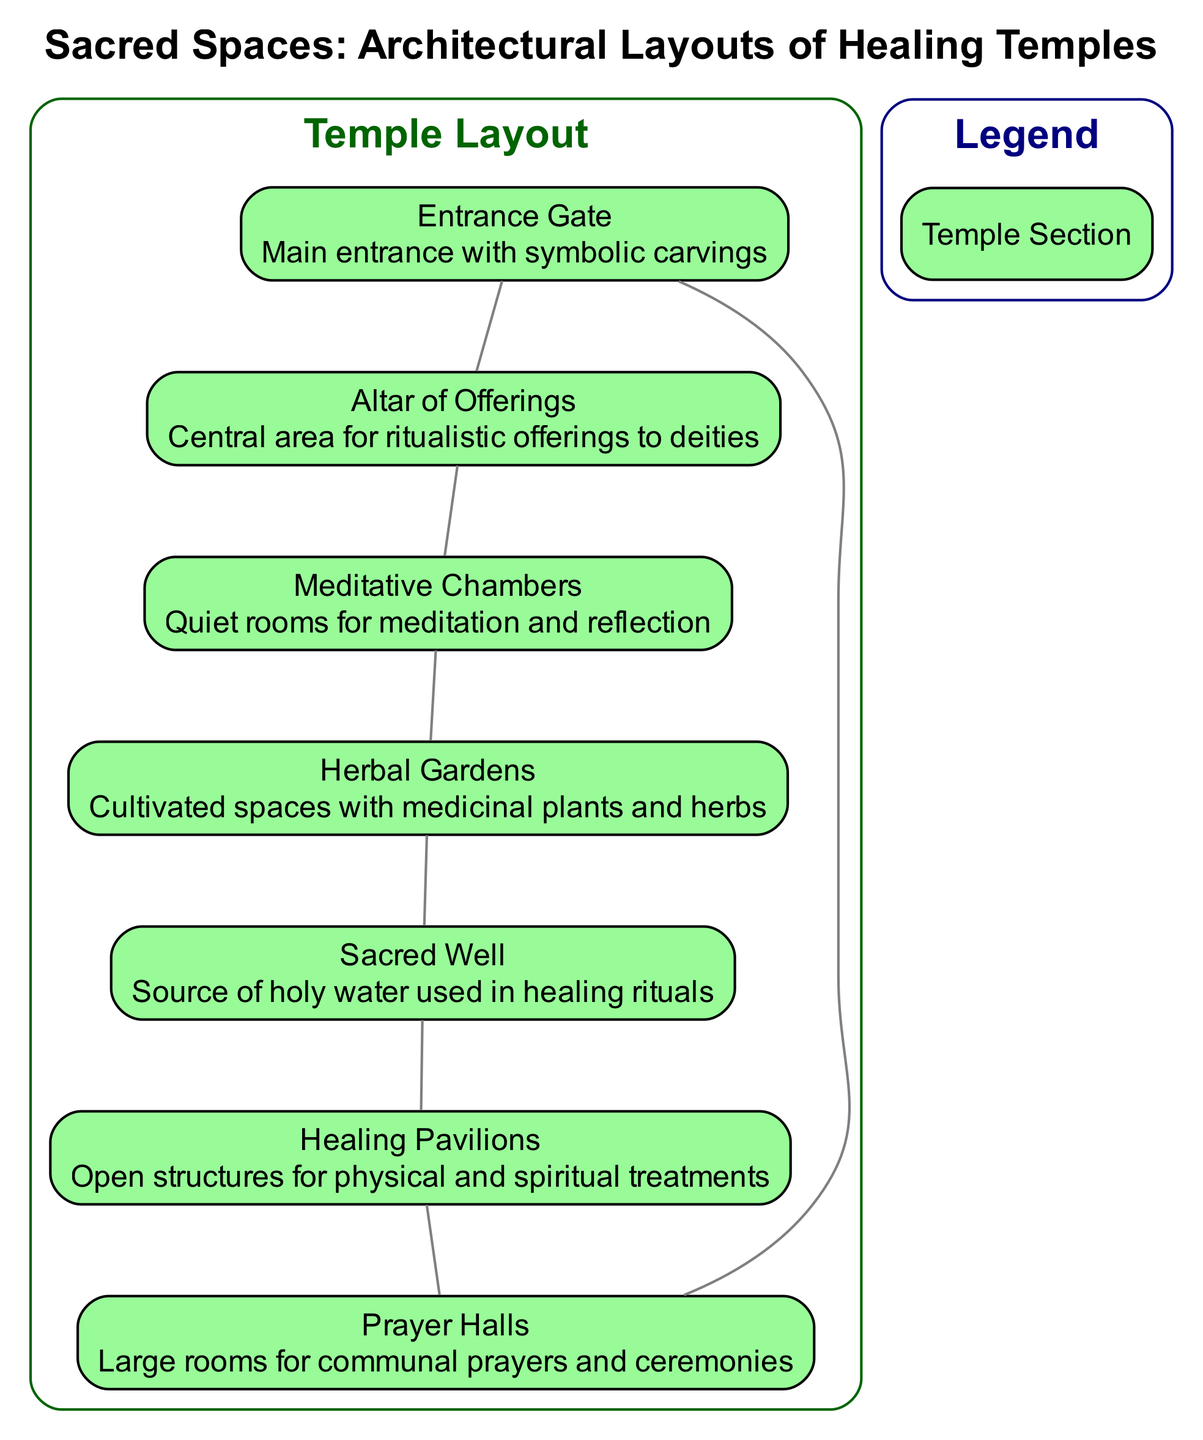What is the main feature found at the entrance of the healing temple? The diagram indicates that the main feature at the entrance is labeled "Entrance Gate" and is described as having symbolic carvings.
Answer: Entrance Gate How many sections are there in the healing temple layout? By counting the sections listed in the diagram, we see that there are a total of 7 sections identified.
Answer: 7 Which area is designated for ritualistic offerings? The diagram specifies the "Altar of Offerings" as the central area dedicated to ritualistic offerings made to deities.
Answer: Altar of Offerings What is the purpose of the Meditative Chambers? According to the diagram, the Meditative Chambers are intended as quiet rooms for meditation and reflection, which highlights their calming purpose.
Answer: Quiet rooms for meditation and reflection Which section provides a source of holy water? The diagram labels the "Sacred Well" as the specific section where holy water used in healing rituals is sourced.
Answer: Sacred Well How does the Healing Pavilions relate to physical treatments? The diagram explains that the Healing Pavilions serve as open structures for physical and spiritual treatments, which suggests their dual role in healing.
Answer: Open structures for physical and spiritual treatments What connects the different sections of the healing temple? The edges between the sections in the diagram indicate that they are connected in a circular layout, which enhances the flow within the temple spaces.
Answer: Circular layout In which area are medicinal plants cultivated? The section labeled "Herbal Gardens" is indicated in the diagram as the cultivated space where medicinal plants and herbs are found.
Answer: Herbal Gardens Which part of the temple is designed for communal prayers? From the visual information in the diagram, the "Prayer Halls" are specified as large rooms used for communal prayers and ceremonies.
Answer: Prayer Halls 